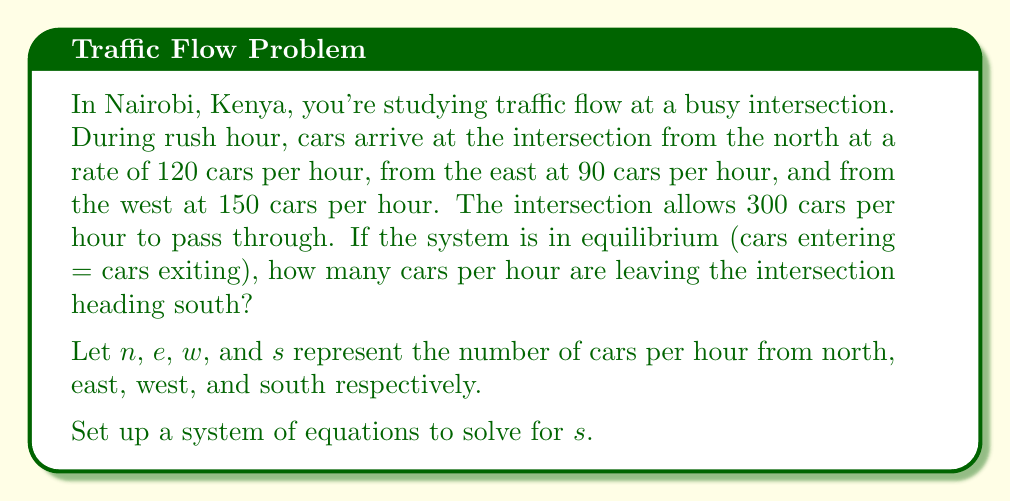Help me with this question. To solve this problem, we'll use a system of equations approach:

1) First, let's establish our equation based on the equilibrium condition:
   Cars entering = Cars exiting
   $n + e + w = 300 + s$

2) We know the values for $n$, $e$, and $w$:
   $n = 120$
   $e = 90$
   $w = 150$

3) Substituting these values into our equation:
   $120 + 90 + 150 = 300 + s$

4) Simplify the left side:
   $360 = 300 + s$

5) Subtract 300 from both sides:
   $60 = s$

Therefore, 60 cars per hour are leaving the intersection heading south.
Answer: 60 cars/hour 